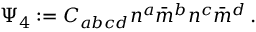<formula> <loc_0><loc_0><loc_500><loc_500>\Psi _ { 4 } \colon = C _ { a b c d } n ^ { a } { \bar { m } } ^ { b } n ^ { c } { \bar { m } } ^ { d } \, .</formula> 